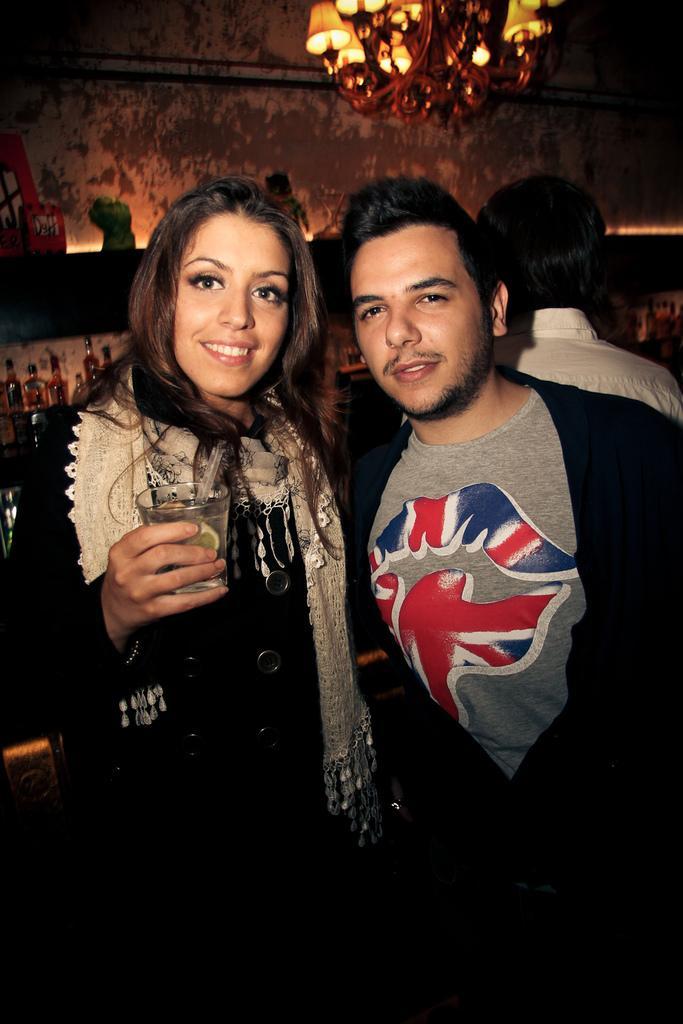Could you give a brief overview of what you see in this image? In the foreground of the picture I can see two persons. There is a woman on the left side holding a glass in her right hand. I can see a man on the right side wearing a black color T-shirt. I can see another man on the top right side. I can see the decorative lighting arrangement at the top of the picture. 